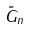Convert formula to latex. <formula><loc_0><loc_0><loc_500><loc_500>\tilde { G } _ { n }</formula> 